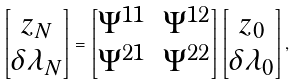<formula> <loc_0><loc_0><loc_500><loc_500>\begin{bmatrix} z _ { N } \\ \delta \lambda _ { N } \end{bmatrix} = \begin{bmatrix} \Psi ^ { 1 1 } & \Psi ^ { 1 2 } \\ \Psi ^ { 2 1 } & \Psi ^ { 2 2 } \end{bmatrix} \begin{bmatrix} z _ { 0 } \\ \delta \lambda _ { 0 } \end{bmatrix} ,</formula> 